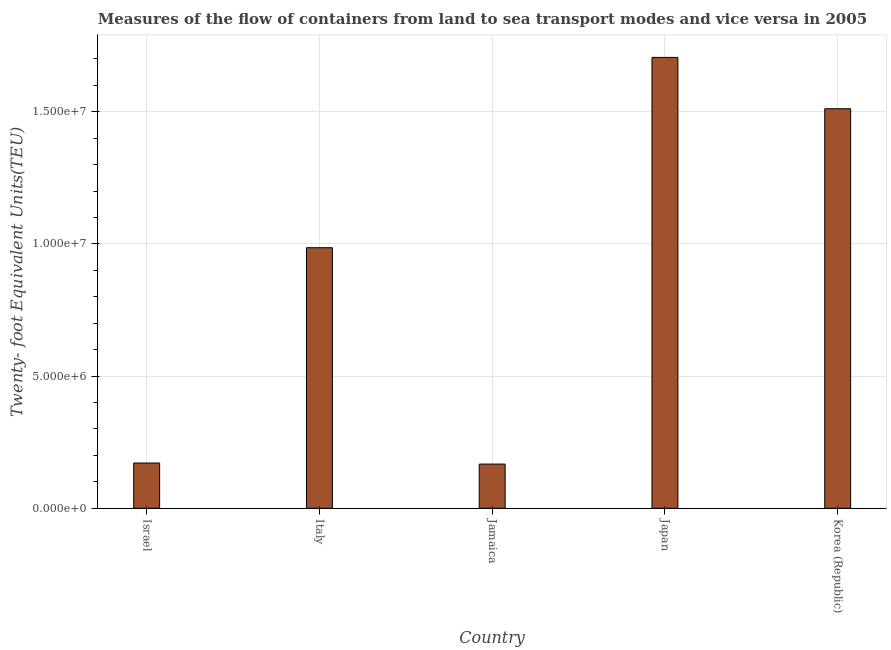Does the graph contain any zero values?
Make the answer very short. No. What is the title of the graph?
Give a very brief answer. Measures of the flow of containers from land to sea transport modes and vice versa in 2005. What is the label or title of the Y-axis?
Make the answer very short. Twenty- foot Equivalent Units(TEU). What is the container port traffic in Korea (Republic)?
Keep it short and to the point. 1.51e+07. Across all countries, what is the maximum container port traffic?
Ensure brevity in your answer.  1.71e+07. Across all countries, what is the minimum container port traffic?
Provide a short and direct response. 1.67e+06. In which country was the container port traffic maximum?
Offer a very short reply. Japan. In which country was the container port traffic minimum?
Your answer should be compact. Jamaica. What is the sum of the container port traffic?
Make the answer very short. 4.54e+07. What is the difference between the container port traffic in Italy and Korea (Republic)?
Provide a succinct answer. -5.26e+06. What is the average container port traffic per country?
Offer a very short reply. 9.08e+06. What is the median container port traffic?
Offer a very short reply. 9.86e+06. What is the ratio of the container port traffic in Italy to that in Korea (Republic)?
Offer a very short reply. 0.65. Is the container port traffic in Italy less than that in Korea (Republic)?
Provide a short and direct response. Yes. Is the difference between the container port traffic in Israel and Italy greater than the difference between any two countries?
Offer a very short reply. No. What is the difference between the highest and the second highest container port traffic?
Give a very brief answer. 1.94e+06. Is the sum of the container port traffic in Japan and Korea (Republic) greater than the maximum container port traffic across all countries?
Make the answer very short. Yes. What is the difference between the highest and the lowest container port traffic?
Offer a very short reply. 1.54e+07. In how many countries, is the container port traffic greater than the average container port traffic taken over all countries?
Keep it short and to the point. 3. How many bars are there?
Your answer should be compact. 5. How many countries are there in the graph?
Your response must be concise. 5. What is the difference between two consecutive major ticks on the Y-axis?
Ensure brevity in your answer.  5.00e+06. Are the values on the major ticks of Y-axis written in scientific E-notation?
Offer a very short reply. Yes. What is the Twenty- foot Equivalent Units(TEU) in Israel?
Your answer should be very brief. 1.71e+06. What is the Twenty- foot Equivalent Units(TEU) in Italy?
Offer a terse response. 9.86e+06. What is the Twenty- foot Equivalent Units(TEU) in Jamaica?
Provide a short and direct response. 1.67e+06. What is the Twenty- foot Equivalent Units(TEU) of Japan?
Your answer should be very brief. 1.71e+07. What is the Twenty- foot Equivalent Units(TEU) in Korea (Republic)?
Give a very brief answer. 1.51e+07. What is the difference between the Twenty- foot Equivalent Units(TEU) in Israel and Italy?
Provide a short and direct response. -8.14e+06. What is the difference between the Twenty- foot Equivalent Units(TEU) in Israel and Jamaica?
Keep it short and to the point. 4.05e+04. What is the difference between the Twenty- foot Equivalent Units(TEU) in Israel and Japan?
Give a very brief answer. -1.53e+07. What is the difference between the Twenty- foot Equivalent Units(TEU) in Israel and Korea (Republic)?
Provide a short and direct response. -1.34e+07. What is the difference between the Twenty- foot Equivalent Units(TEU) in Italy and Jamaica?
Your answer should be very brief. 8.18e+06. What is the difference between the Twenty- foot Equivalent Units(TEU) in Italy and Japan?
Offer a very short reply. -7.20e+06. What is the difference between the Twenty- foot Equivalent Units(TEU) in Italy and Korea (Republic)?
Offer a very short reply. -5.26e+06. What is the difference between the Twenty- foot Equivalent Units(TEU) in Jamaica and Japan?
Your answer should be very brief. -1.54e+07. What is the difference between the Twenty- foot Equivalent Units(TEU) in Jamaica and Korea (Republic)?
Your response must be concise. -1.34e+07. What is the difference between the Twenty- foot Equivalent Units(TEU) in Japan and Korea (Republic)?
Ensure brevity in your answer.  1.94e+06. What is the ratio of the Twenty- foot Equivalent Units(TEU) in Israel to that in Italy?
Offer a very short reply. 0.17. What is the ratio of the Twenty- foot Equivalent Units(TEU) in Israel to that in Jamaica?
Your response must be concise. 1.02. What is the ratio of the Twenty- foot Equivalent Units(TEU) in Israel to that in Korea (Republic)?
Keep it short and to the point. 0.11. What is the ratio of the Twenty- foot Equivalent Units(TEU) in Italy to that in Jamaica?
Ensure brevity in your answer.  5.9. What is the ratio of the Twenty- foot Equivalent Units(TEU) in Italy to that in Japan?
Provide a short and direct response. 0.58. What is the ratio of the Twenty- foot Equivalent Units(TEU) in Italy to that in Korea (Republic)?
Your answer should be compact. 0.65. What is the ratio of the Twenty- foot Equivalent Units(TEU) in Jamaica to that in Japan?
Ensure brevity in your answer.  0.1. What is the ratio of the Twenty- foot Equivalent Units(TEU) in Jamaica to that in Korea (Republic)?
Offer a terse response. 0.11. What is the ratio of the Twenty- foot Equivalent Units(TEU) in Japan to that in Korea (Republic)?
Ensure brevity in your answer.  1.13. 